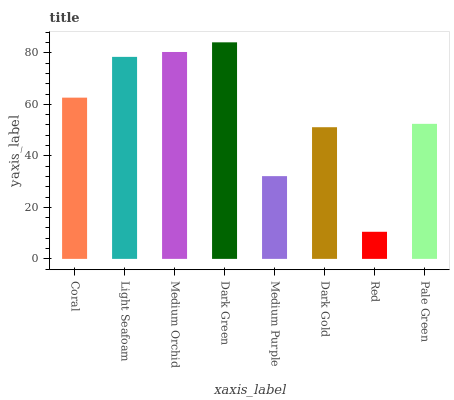Is Light Seafoam the minimum?
Answer yes or no. No. Is Light Seafoam the maximum?
Answer yes or no. No. Is Light Seafoam greater than Coral?
Answer yes or no. Yes. Is Coral less than Light Seafoam?
Answer yes or no. Yes. Is Coral greater than Light Seafoam?
Answer yes or no. No. Is Light Seafoam less than Coral?
Answer yes or no. No. Is Coral the high median?
Answer yes or no. Yes. Is Pale Green the low median?
Answer yes or no. Yes. Is Medium Purple the high median?
Answer yes or no. No. Is Coral the low median?
Answer yes or no. No. 